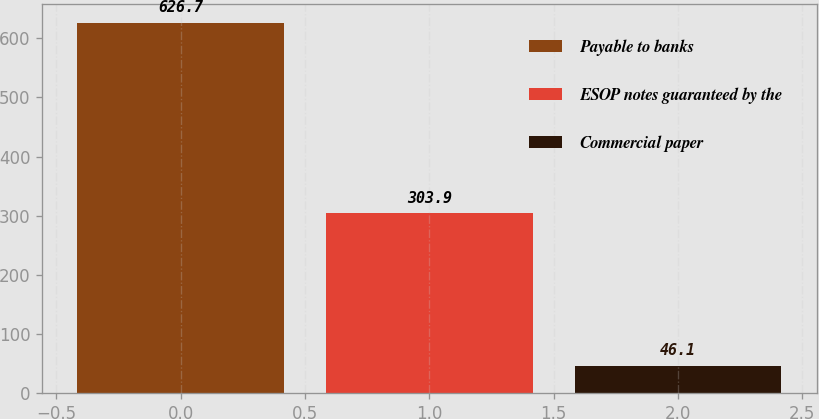Convert chart. <chart><loc_0><loc_0><loc_500><loc_500><bar_chart><fcel>Payable to banks<fcel>ESOP notes guaranteed by the<fcel>Commercial paper<nl><fcel>626.7<fcel>303.9<fcel>46.1<nl></chart> 